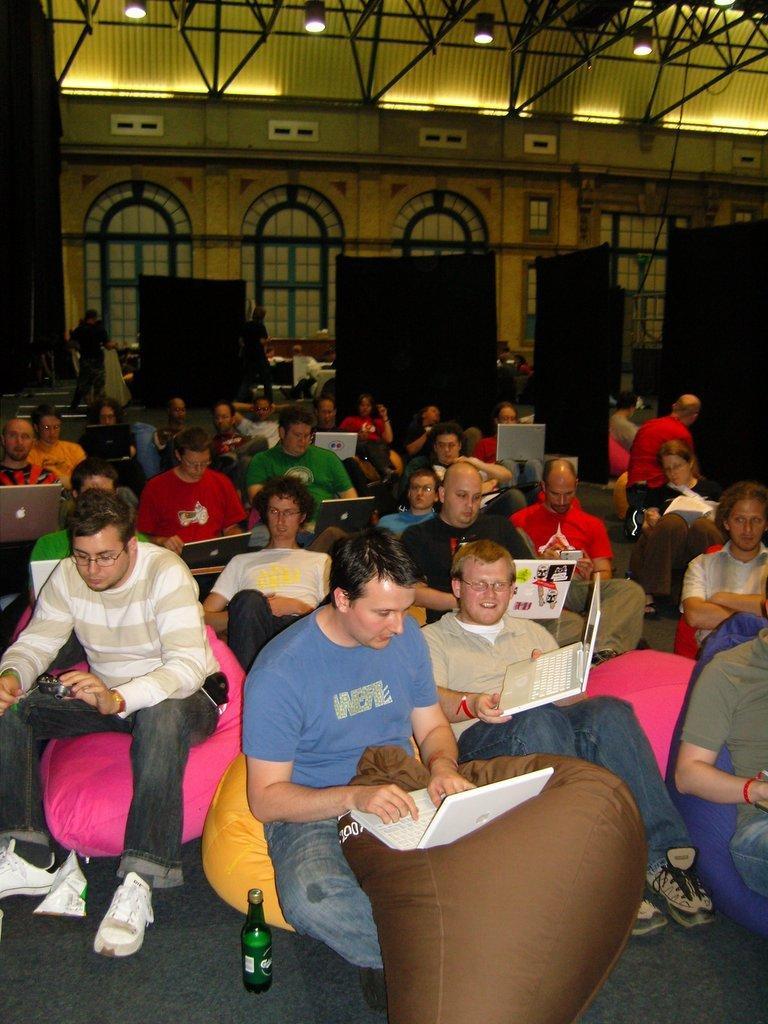Could you give a brief overview of what you see in this image? There are people sitting in the foreground area of the image, some are having laptops. There are lamps, arches and doors in the background. 